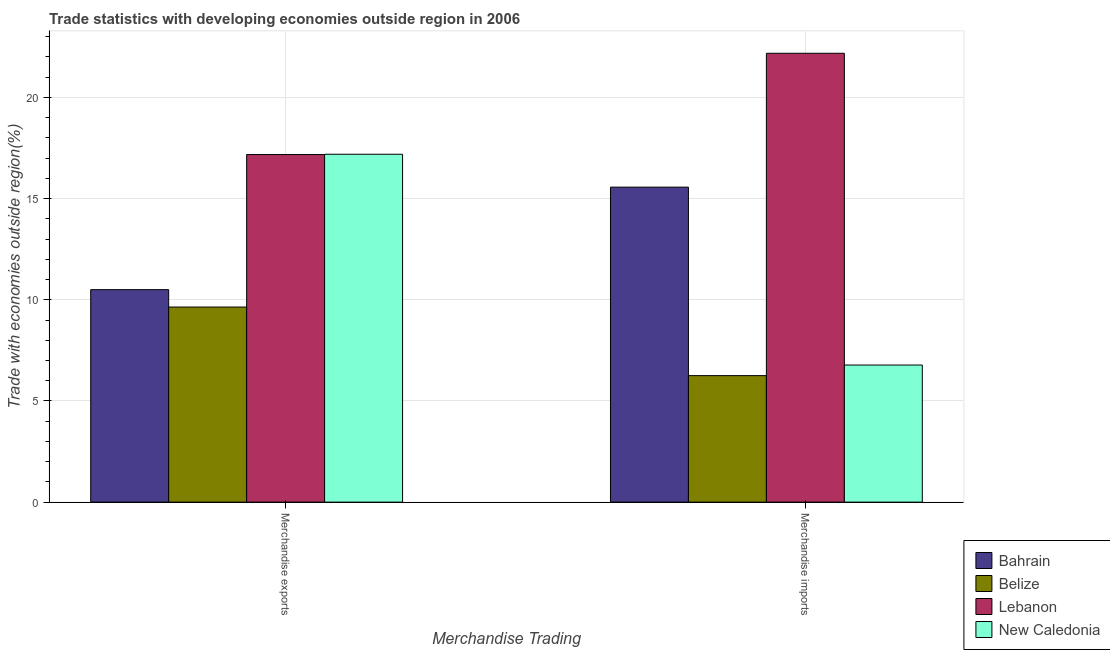Are the number of bars per tick equal to the number of legend labels?
Keep it short and to the point. Yes. How many bars are there on the 2nd tick from the left?
Offer a very short reply. 4. What is the merchandise exports in New Caledonia?
Ensure brevity in your answer.  17.19. Across all countries, what is the maximum merchandise exports?
Ensure brevity in your answer.  17.19. Across all countries, what is the minimum merchandise imports?
Give a very brief answer. 6.25. In which country was the merchandise imports maximum?
Keep it short and to the point. Lebanon. In which country was the merchandise imports minimum?
Your response must be concise. Belize. What is the total merchandise exports in the graph?
Make the answer very short. 54.51. What is the difference between the merchandise imports in Lebanon and that in New Caledonia?
Provide a short and direct response. 15.41. What is the difference between the merchandise exports in Lebanon and the merchandise imports in New Caledonia?
Give a very brief answer. 10.4. What is the average merchandise exports per country?
Provide a short and direct response. 13.63. What is the difference between the merchandise imports and merchandise exports in New Caledonia?
Provide a short and direct response. -10.42. What is the ratio of the merchandise exports in Bahrain to that in Belize?
Ensure brevity in your answer.  1.09. Is the merchandise imports in New Caledonia less than that in Belize?
Make the answer very short. No. What does the 1st bar from the left in Merchandise exports represents?
Make the answer very short. Bahrain. What does the 1st bar from the right in Merchandise exports represents?
Provide a succinct answer. New Caledonia. How many bars are there?
Make the answer very short. 8. How many countries are there in the graph?
Give a very brief answer. 4. Does the graph contain grids?
Keep it short and to the point. Yes. Where does the legend appear in the graph?
Offer a very short reply. Bottom right. How many legend labels are there?
Give a very brief answer. 4. What is the title of the graph?
Your answer should be very brief. Trade statistics with developing economies outside region in 2006. Does "Greenland" appear as one of the legend labels in the graph?
Ensure brevity in your answer.  No. What is the label or title of the X-axis?
Offer a terse response. Merchandise Trading. What is the label or title of the Y-axis?
Provide a short and direct response. Trade with economies outside region(%). What is the Trade with economies outside region(%) in Bahrain in Merchandise exports?
Offer a terse response. 10.5. What is the Trade with economies outside region(%) of Belize in Merchandise exports?
Your answer should be compact. 9.64. What is the Trade with economies outside region(%) of Lebanon in Merchandise exports?
Make the answer very short. 17.18. What is the Trade with economies outside region(%) of New Caledonia in Merchandise exports?
Offer a very short reply. 17.19. What is the Trade with economies outside region(%) of Bahrain in Merchandise imports?
Provide a short and direct response. 15.57. What is the Trade with economies outside region(%) of Belize in Merchandise imports?
Keep it short and to the point. 6.25. What is the Trade with economies outside region(%) in Lebanon in Merchandise imports?
Offer a terse response. 22.18. What is the Trade with economies outside region(%) of New Caledonia in Merchandise imports?
Your response must be concise. 6.78. Across all Merchandise Trading, what is the maximum Trade with economies outside region(%) of Bahrain?
Provide a short and direct response. 15.57. Across all Merchandise Trading, what is the maximum Trade with economies outside region(%) in Belize?
Provide a short and direct response. 9.64. Across all Merchandise Trading, what is the maximum Trade with economies outside region(%) in Lebanon?
Offer a very short reply. 22.18. Across all Merchandise Trading, what is the maximum Trade with economies outside region(%) of New Caledonia?
Provide a short and direct response. 17.19. Across all Merchandise Trading, what is the minimum Trade with economies outside region(%) of Bahrain?
Keep it short and to the point. 10.5. Across all Merchandise Trading, what is the minimum Trade with economies outside region(%) of Belize?
Your answer should be compact. 6.25. Across all Merchandise Trading, what is the minimum Trade with economies outside region(%) in Lebanon?
Your response must be concise. 17.18. Across all Merchandise Trading, what is the minimum Trade with economies outside region(%) in New Caledonia?
Give a very brief answer. 6.78. What is the total Trade with economies outside region(%) of Bahrain in the graph?
Make the answer very short. 26.07. What is the total Trade with economies outside region(%) in Belize in the graph?
Your answer should be compact. 15.89. What is the total Trade with economies outside region(%) in Lebanon in the graph?
Ensure brevity in your answer.  39.36. What is the total Trade with economies outside region(%) in New Caledonia in the graph?
Your response must be concise. 23.97. What is the difference between the Trade with economies outside region(%) in Bahrain in Merchandise exports and that in Merchandise imports?
Your answer should be very brief. -5.07. What is the difference between the Trade with economies outside region(%) in Belize in Merchandise exports and that in Merchandise imports?
Your answer should be compact. 3.39. What is the difference between the Trade with economies outside region(%) in Lebanon in Merchandise exports and that in Merchandise imports?
Keep it short and to the point. -5. What is the difference between the Trade with economies outside region(%) of New Caledonia in Merchandise exports and that in Merchandise imports?
Your response must be concise. 10.42. What is the difference between the Trade with economies outside region(%) in Bahrain in Merchandise exports and the Trade with economies outside region(%) in Belize in Merchandise imports?
Offer a terse response. 4.25. What is the difference between the Trade with economies outside region(%) in Bahrain in Merchandise exports and the Trade with economies outside region(%) in Lebanon in Merchandise imports?
Your answer should be compact. -11.68. What is the difference between the Trade with economies outside region(%) in Bahrain in Merchandise exports and the Trade with economies outside region(%) in New Caledonia in Merchandise imports?
Provide a succinct answer. 3.73. What is the difference between the Trade with economies outside region(%) of Belize in Merchandise exports and the Trade with economies outside region(%) of Lebanon in Merchandise imports?
Your answer should be very brief. -12.54. What is the difference between the Trade with economies outside region(%) in Belize in Merchandise exports and the Trade with economies outside region(%) in New Caledonia in Merchandise imports?
Ensure brevity in your answer.  2.87. What is the difference between the Trade with economies outside region(%) in Lebanon in Merchandise exports and the Trade with economies outside region(%) in New Caledonia in Merchandise imports?
Give a very brief answer. 10.4. What is the average Trade with economies outside region(%) in Bahrain per Merchandise Trading?
Provide a short and direct response. 13.03. What is the average Trade with economies outside region(%) of Belize per Merchandise Trading?
Your response must be concise. 7.95. What is the average Trade with economies outside region(%) in Lebanon per Merchandise Trading?
Provide a succinct answer. 19.68. What is the average Trade with economies outside region(%) of New Caledonia per Merchandise Trading?
Make the answer very short. 11.98. What is the difference between the Trade with economies outside region(%) of Bahrain and Trade with economies outside region(%) of Belize in Merchandise exports?
Ensure brevity in your answer.  0.86. What is the difference between the Trade with economies outside region(%) in Bahrain and Trade with economies outside region(%) in Lebanon in Merchandise exports?
Your answer should be very brief. -6.68. What is the difference between the Trade with economies outside region(%) in Bahrain and Trade with economies outside region(%) in New Caledonia in Merchandise exports?
Provide a succinct answer. -6.69. What is the difference between the Trade with economies outside region(%) of Belize and Trade with economies outside region(%) of Lebanon in Merchandise exports?
Keep it short and to the point. -7.54. What is the difference between the Trade with economies outside region(%) in Belize and Trade with economies outside region(%) in New Caledonia in Merchandise exports?
Ensure brevity in your answer.  -7.55. What is the difference between the Trade with economies outside region(%) in Lebanon and Trade with economies outside region(%) in New Caledonia in Merchandise exports?
Provide a succinct answer. -0.01. What is the difference between the Trade with economies outside region(%) in Bahrain and Trade with economies outside region(%) in Belize in Merchandise imports?
Keep it short and to the point. 9.32. What is the difference between the Trade with economies outside region(%) of Bahrain and Trade with economies outside region(%) of Lebanon in Merchandise imports?
Provide a short and direct response. -6.62. What is the difference between the Trade with economies outside region(%) in Bahrain and Trade with economies outside region(%) in New Caledonia in Merchandise imports?
Offer a very short reply. 8.79. What is the difference between the Trade with economies outside region(%) of Belize and Trade with economies outside region(%) of Lebanon in Merchandise imports?
Your response must be concise. -15.93. What is the difference between the Trade with economies outside region(%) of Belize and Trade with economies outside region(%) of New Caledonia in Merchandise imports?
Ensure brevity in your answer.  -0.52. What is the difference between the Trade with economies outside region(%) of Lebanon and Trade with economies outside region(%) of New Caledonia in Merchandise imports?
Your answer should be compact. 15.41. What is the ratio of the Trade with economies outside region(%) in Bahrain in Merchandise exports to that in Merchandise imports?
Your answer should be compact. 0.67. What is the ratio of the Trade with economies outside region(%) of Belize in Merchandise exports to that in Merchandise imports?
Make the answer very short. 1.54. What is the ratio of the Trade with economies outside region(%) of Lebanon in Merchandise exports to that in Merchandise imports?
Give a very brief answer. 0.77. What is the ratio of the Trade with economies outside region(%) in New Caledonia in Merchandise exports to that in Merchandise imports?
Your answer should be very brief. 2.54. What is the difference between the highest and the second highest Trade with economies outside region(%) of Bahrain?
Ensure brevity in your answer.  5.07. What is the difference between the highest and the second highest Trade with economies outside region(%) of Belize?
Keep it short and to the point. 3.39. What is the difference between the highest and the second highest Trade with economies outside region(%) in Lebanon?
Your answer should be compact. 5. What is the difference between the highest and the second highest Trade with economies outside region(%) in New Caledonia?
Give a very brief answer. 10.42. What is the difference between the highest and the lowest Trade with economies outside region(%) of Bahrain?
Your response must be concise. 5.07. What is the difference between the highest and the lowest Trade with economies outside region(%) in Belize?
Make the answer very short. 3.39. What is the difference between the highest and the lowest Trade with economies outside region(%) in Lebanon?
Your response must be concise. 5. What is the difference between the highest and the lowest Trade with economies outside region(%) in New Caledonia?
Ensure brevity in your answer.  10.42. 